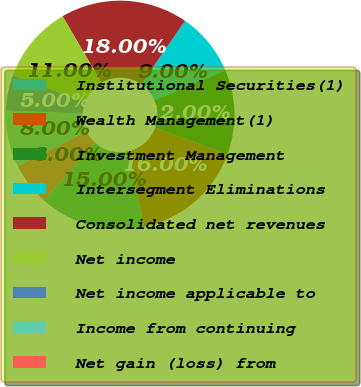Convert chart. <chart><loc_0><loc_0><loc_500><loc_500><pie_chart><fcel>Institutional Securities(1)<fcel>Wealth Management(1)<fcel>Investment Management<fcel>Intersegment Eliminations<fcel>Consolidated net revenues<fcel>Net income<fcel>Net income applicable to<fcel>Income from continuing<fcel>Net gain (loss) from<nl><fcel>15.0%<fcel>16.0%<fcel>12.0%<fcel>9.0%<fcel>18.0%<fcel>11.0%<fcel>5.0%<fcel>8.0%<fcel>6.0%<nl></chart> 